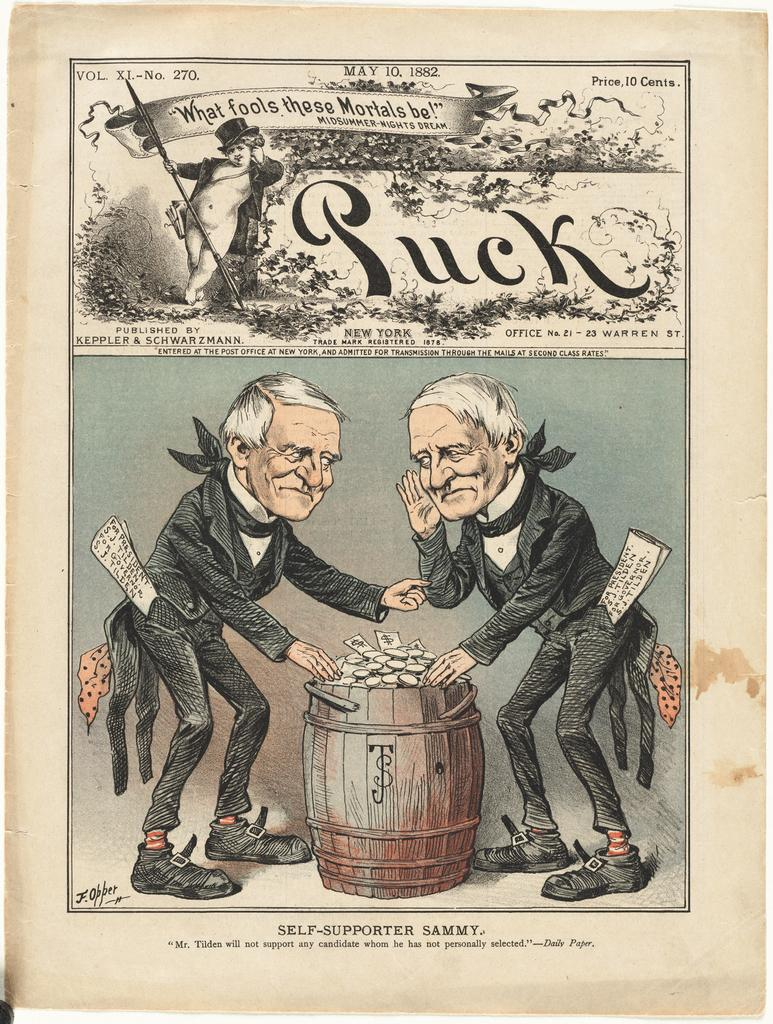<image>
Write a terse but informative summary of the picture. A colored illustration page that has the word luck on the top of two men next to a barrel. 